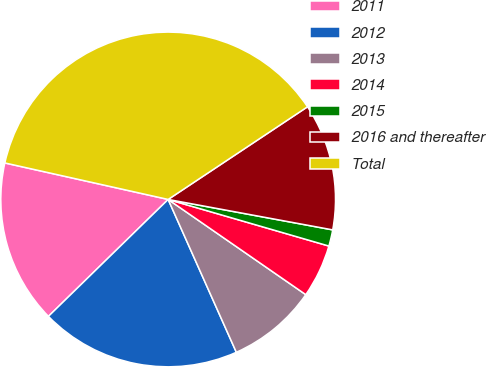Convert chart. <chart><loc_0><loc_0><loc_500><loc_500><pie_chart><fcel>2011<fcel>2012<fcel>2013<fcel>2014<fcel>2015<fcel>2016 and thereafter<fcel>Total<nl><fcel>15.81%<fcel>19.37%<fcel>8.69%<fcel>5.14%<fcel>1.58%<fcel>12.25%<fcel>37.16%<nl></chart> 